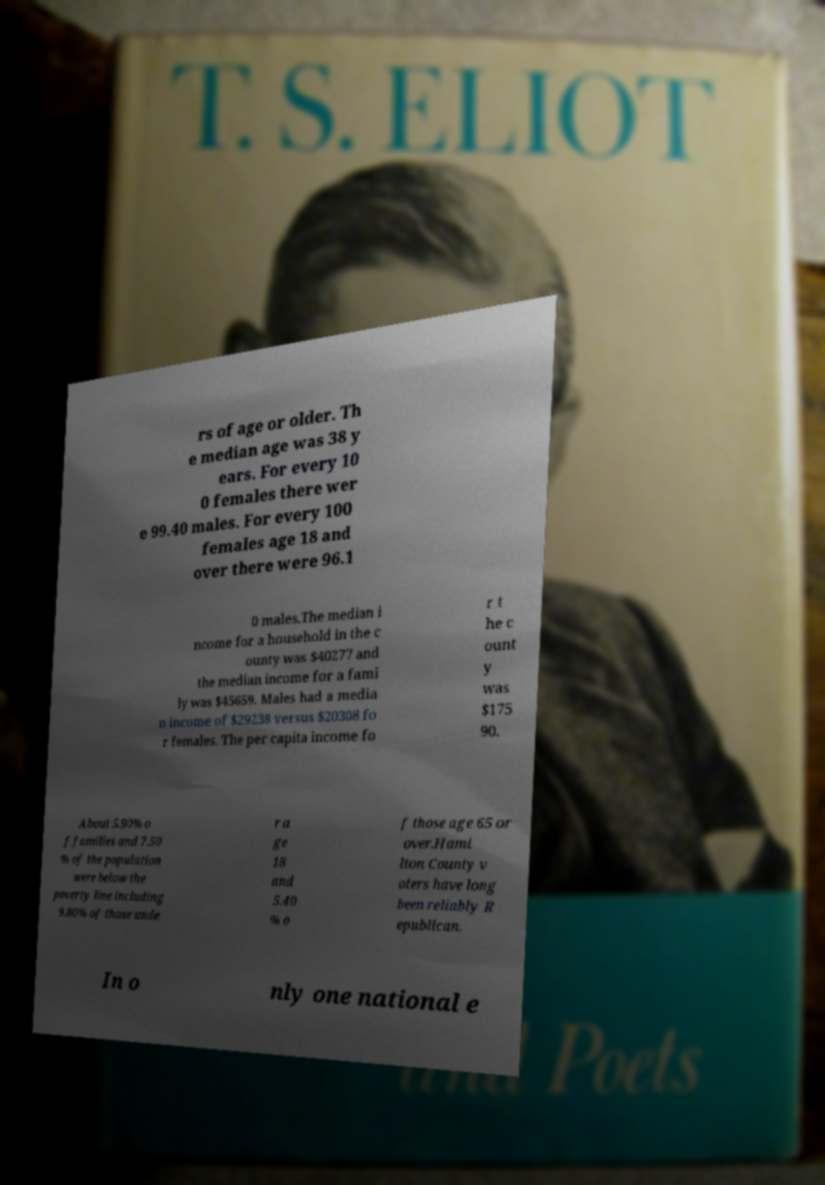What messages or text are displayed in this image? I need them in a readable, typed format. rs of age or older. Th e median age was 38 y ears. For every 10 0 females there wer e 99.40 males. For every 100 females age 18 and over there were 96.1 0 males.The median i ncome for a household in the c ounty was $40277 and the median income for a fami ly was $45659. Males had a media n income of $29238 versus $20308 fo r females. The per capita income fo r t he c ount y was $175 90. About 5.90% o f families and 7.50 % of the population were below the poverty line including 9.80% of those unde r a ge 18 and 5.40 % o f those age 65 or over.Hami lton County v oters have long been reliably R epublican. In o nly one national e 